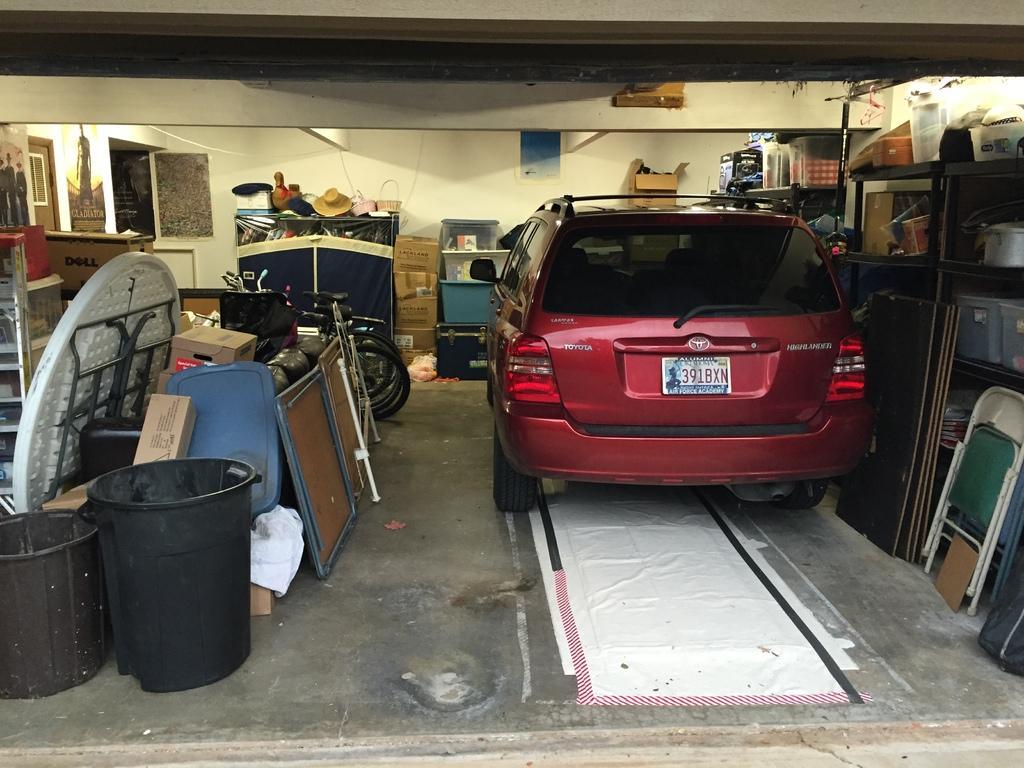Describe this image in one or two sentences. In this image we can see car, chairs, objects placed in shelves, speakers, ventilator, posters, dining table, containers, bicycles, light and wall. 